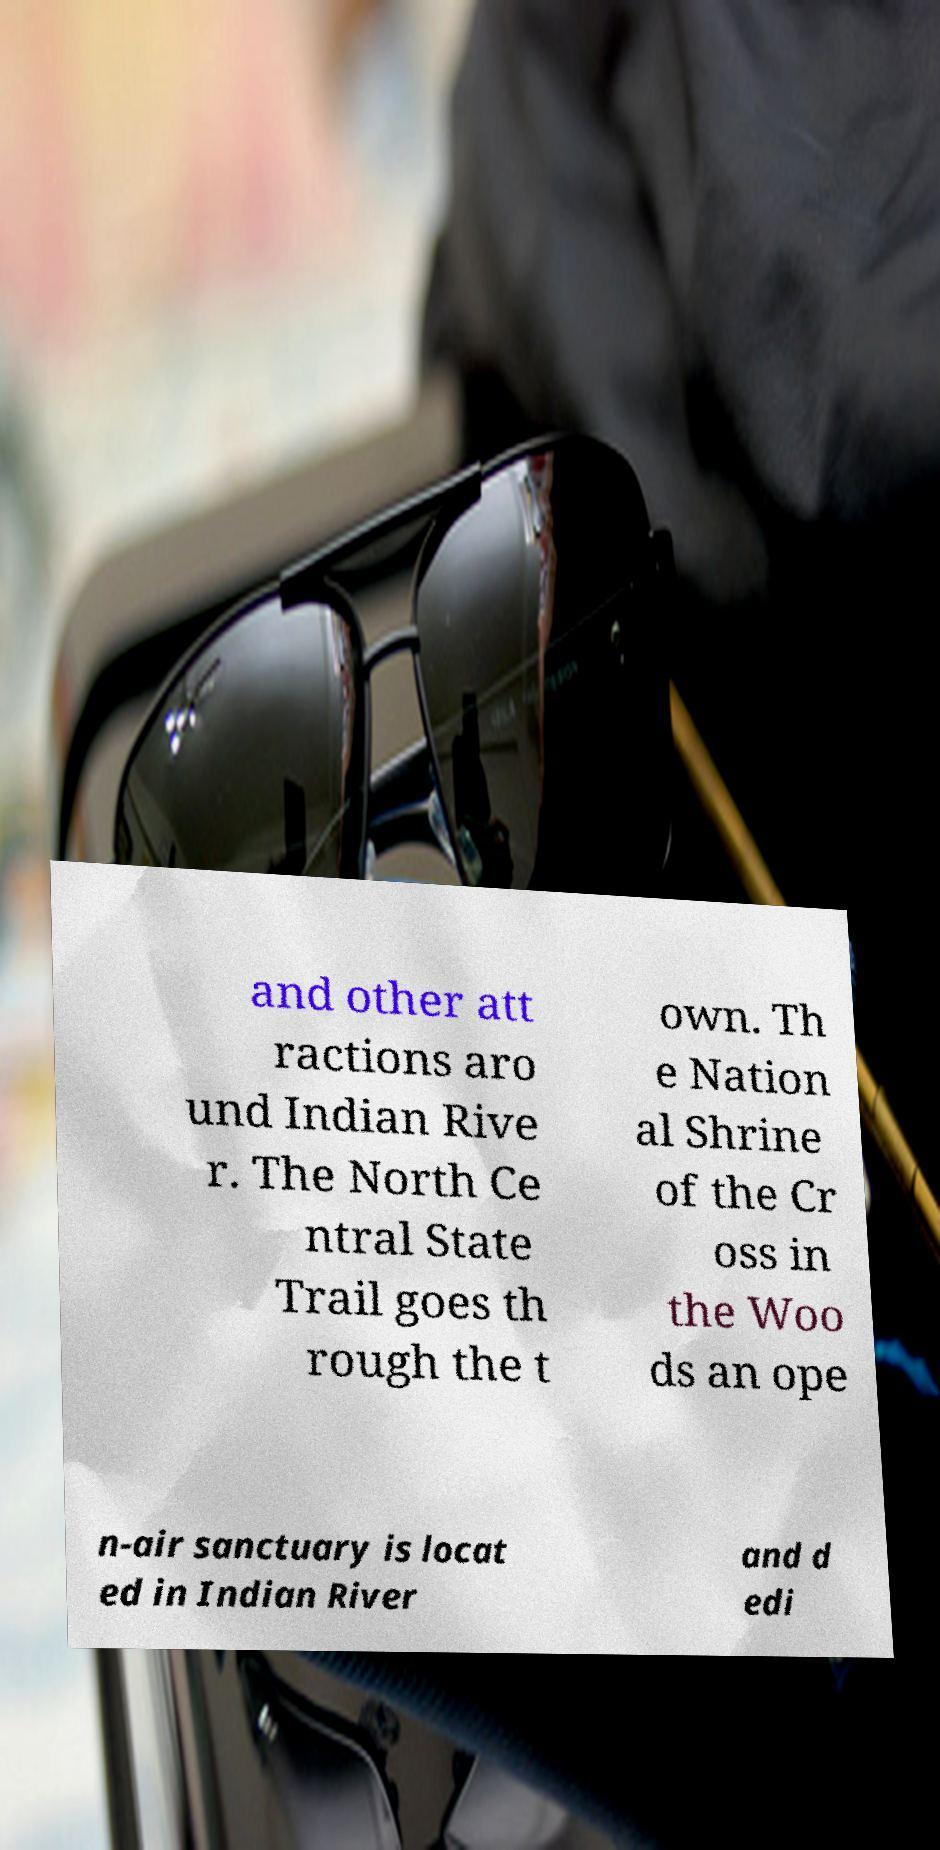Please identify and transcribe the text found in this image. and other att ractions aro und Indian Rive r. The North Ce ntral State Trail goes th rough the t own. Th e Nation al Shrine of the Cr oss in the Woo ds an ope n-air sanctuary is locat ed in Indian River and d edi 